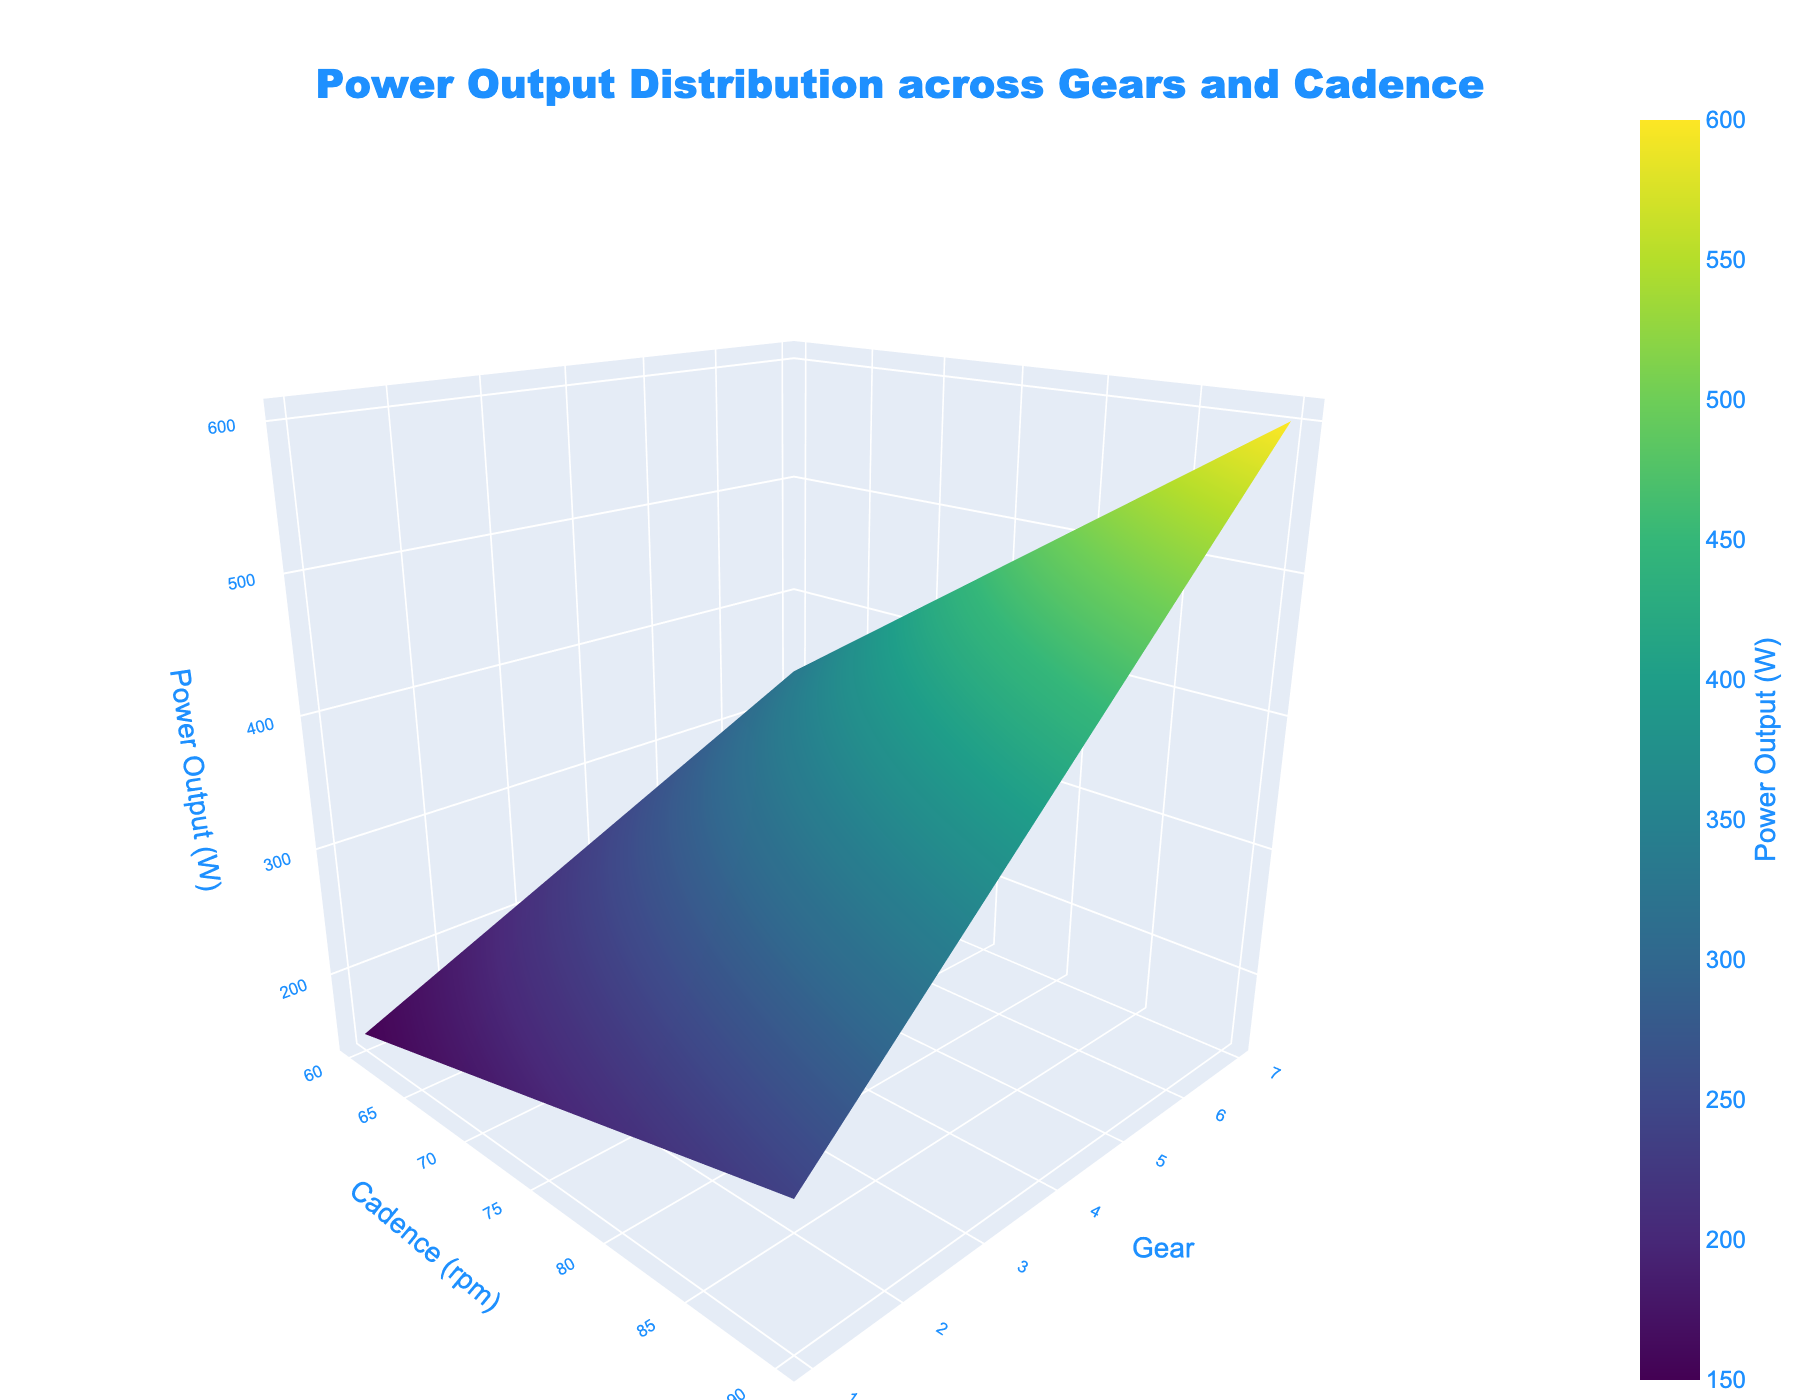What is the title of the plot? The title of the plot is written at the top and centered. It reads 'Power Output Distribution across Gears and Cadence'.
Answer: Power Output Distribution across Gears and Cadence Which axis represents the cadence? The x-axis represents the cadence as indicated by the x-axis title 'Cadence (rpm)'.
Answer: x-axis What is the power output at Gear 5 and Cadence 80 rpm? To find the power output at Gear 5 and Cadence 80 rpm, locate the intersection of Gear 5 on the y-axis and Cadence 80 rpm on the x-axis. The z-value at this point is the Power Output, which is 410 W.
Answer: 410 W How does the power output change as the cadence increases for Gear 3? Observing the z-values along the x-axis for Gear 3, starting from 210 W at Cadence 60 and increasing to 360 W at Cadence 90, indicates a rise in Power Output as Cadence increases.
Answer: Increases Compare the power outputs at Gear 2, Cadence 70 rpm and Gear 4, Cadence 70 rpm. Which is higher? Locate Gear 2 and Cadence 70 rpm, and Gear 4 and Cadence 70 rpm. The Power Output for Gear 2 is 220 W, while for Gear 4 it is 300 W. Thus, Gear 4 has a higher Power Output.
Answer: Gear 4 What is the difference in power output between Gear 6 at Cadence 90 rpm and Gear 1 at Cadence 60 rpm? The Power Output for Gear 6 at Cadence 90 rpm is 540 W, and for Gear 1 at Cadence 60 rpm is 150 W. The difference is 540 - 150 = 390 W.
Answer: 390 W What is the average power output for Gear 3 across all cadences? Sum the power outputs for Gear 3 (210, 260, 310, 360) and divide by the number of values: (210 + 260 + 310 + 360) / 4 = 1140 / 4 = 285 W.
Answer: 285 W At which cadence and gear combination is the power output highest? Examine the peaks on the surface plot for the highest z-value, which occurs at Gear 7, Cadence 90 rpm with a power output of 600 W.
Answer: Gear 7, Cadence 90 rpm Is there a gear where the power output remains constant regardless of cadence? By observing the surface plot, none of the gears show a constant power output across different cadences; power output changes with cadence in all gears.
Answer: No Which gear shows the most significant increase in power output when moving from Cadence 60 rpm to 90 rpm? Compare the increase in Power Output from Cadence 60 rpm to 90 rpm for each gear. Gear 7 shows the highest increase, from 330 W to 600 W, an increase of 270 W.
Answer: Gear 7 